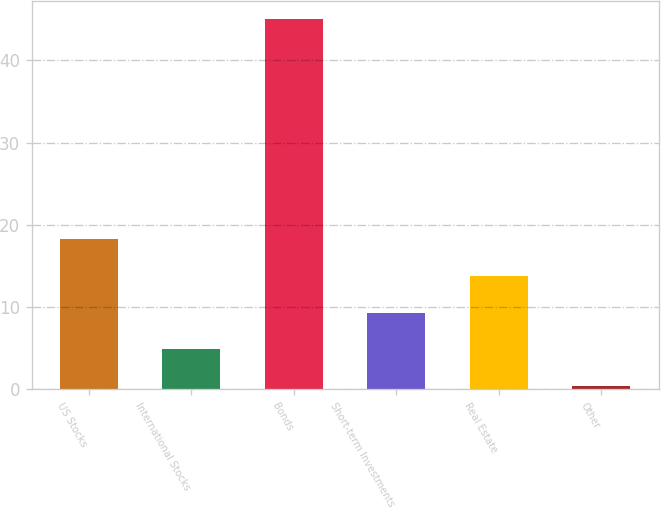Convert chart to OTSL. <chart><loc_0><loc_0><loc_500><loc_500><bar_chart><fcel>US Stocks<fcel>International Stocks<fcel>Bonds<fcel>Short-term Investments<fcel>Real Estate<fcel>Other<nl><fcel>18.22<fcel>4.84<fcel>45<fcel>9.3<fcel>13.76<fcel>0.38<nl></chart> 